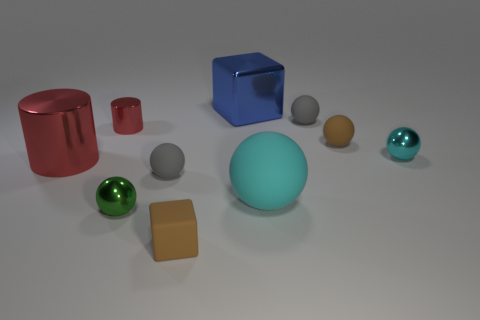What number of small matte balls are the same color as the rubber block?
Your answer should be very brief. 1. There is a tiny object that is the same color as the big matte sphere; what is its material?
Ensure brevity in your answer.  Metal. Are there more gray balls on the left side of the brown rubber block than gray cylinders?
Ensure brevity in your answer.  Yes. Do the blue metallic object and the tiny green shiny object have the same shape?
Your answer should be compact. No. What number of big cylinders have the same material as the blue cube?
Your answer should be very brief. 1. What is the size of the brown thing that is the same shape as the cyan metal object?
Provide a short and direct response. Small. Is the brown rubber ball the same size as the green shiny thing?
Provide a short and direct response. Yes. There is a red thing that is to the left of the small red cylinder that is behind the small green shiny sphere that is in front of the cyan shiny ball; what shape is it?
Make the answer very short. Cylinder. There is another small metal thing that is the same shape as the green metallic object; what is its color?
Provide a short and direct response. Cyan. What size is the sphere that is both behind the cyan matte thing and in front of the big metallic cylinder?
Keep it short and to the point. Small. 